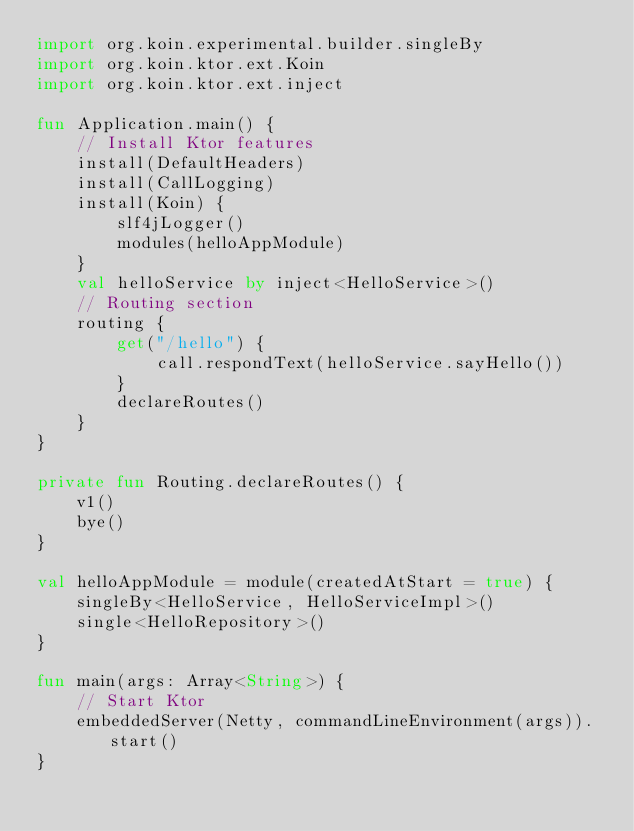<code> <loc_0><loc_0><loc_500><loc_500><_Kotlin_>import org.koin.experimental.builder.singleBy
import org.koin.ktor.ext.Koin
import org.koin.ktor.ext.inject

fun Application.main() {
    // Install Ktor features
    install(DefaultHeaders)
    install(CallLogging)
    install(Koin) {
        slf4jLogger()
        modules(helloAppModule)
    }
    val helloService by inject<HelloService>()
    // Routing section
    routing {
        get("/hello") {
            call.respondText(helloService.sayHello())
        }
        declareRoutes()
    }
}

private fun Routing.declareRoutes() {
    v1()
    bye()
}

val helloAppModule = module(createdAtStart = true) {
    singleBy<HelloService, HelloServiceImpl>()
    single<HelloRepository>()
}

fun main(args: Array<String>) {
    // Start Ktor
    embeddedServer(Netty, commandLineEnvironment(args)).start()
}
</code> 